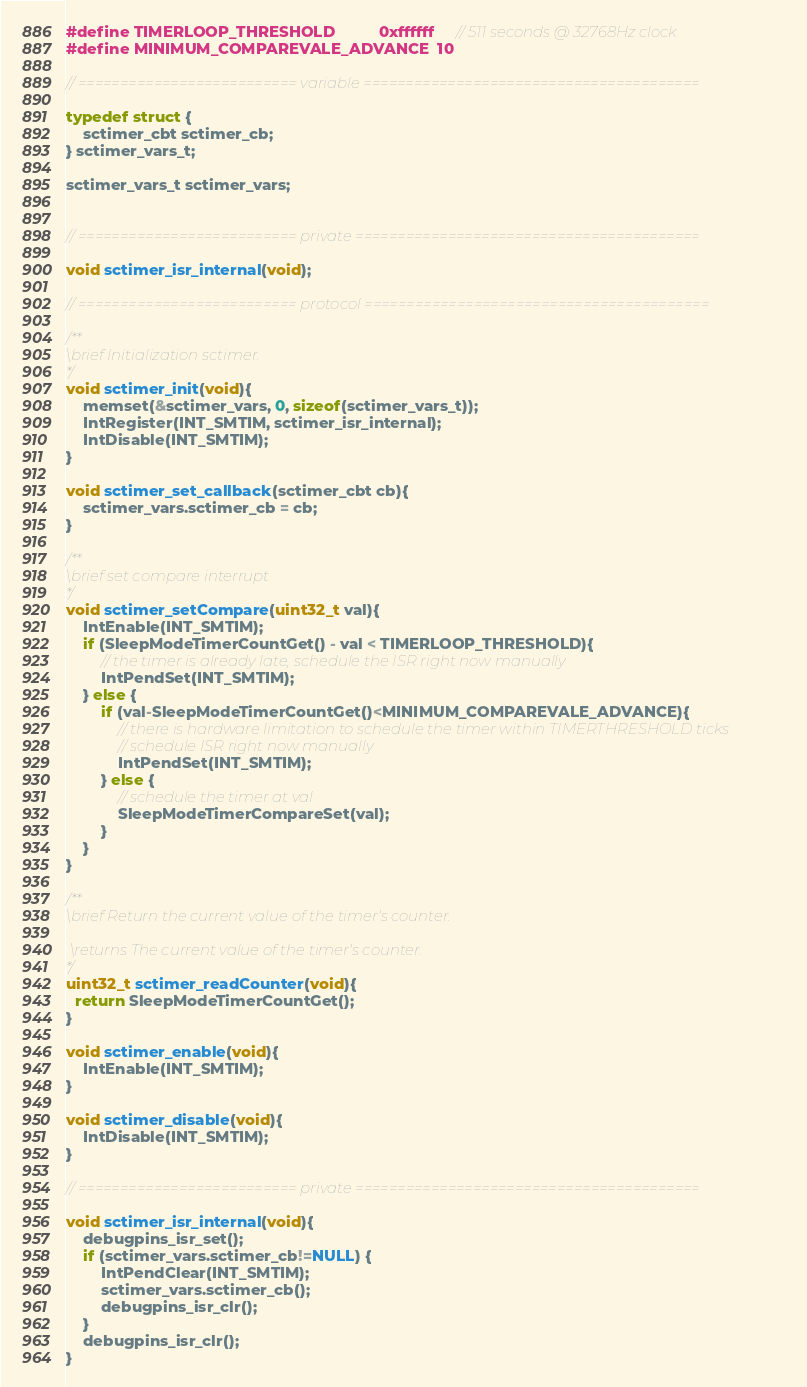Convert code to text. <code><loc_0><loc_0><loc_500><loc_500><_C_>
#define TIMERLOOP_THRESHOLD          0xffffff     // 511 seconds @ 32768Hz clock
#define MINIMUM_COMPAREVALE_ADVANCE  10

// ========================== variable ========================================

typedef struct {
    sctimer_cbt sctimer_cb;
} sctimer_vars_t;

sctimer_vars_t sctimer_vars;


// ========================== private =========================================

void sctimer_isr_internal(void);

// ========================== protocol =========================================

/**
\brief Initialization sctimer.
*/
void sctimer_init(void){
    memset(&sctimer_vars, 0, sizeof(sctimer_vars_t));
    IntRegister(INT_SMTIM, sctimer_isr_internal);
    IntDisable(INT_SMTIM);
}

void sctimer_set_callback(sctimer_cbt cb){
    sctimer_vars.sctimer_cb = cb;
}

/**
\brief set compare interrupt
*/
void sctimer_setCompare(uint32_t val){
    IntEnable(INT_SMTIM);
    if (SleepModeTimerCountGet() - val < TIMERLOOP_THRESHOLD){
        // the timer is already late, schedule the ISR right now manually 
        IntPendSet(INT_SMTIM);
    } else {
        if (val-SleepModeTimerCountGet()<MINIMUM_COMPAREVALE_ADVANCE){
            // there is hardware limitation to schedule the timer within TIMERTHRESHOLD ticks
            // schedule ISR right now manually
            IntPendSet(INT_SMTIM);
        } else {
            // schedule the timer at val
            SleepModeTimerCompareSet(val);
        }
    }
}

/**
\brief Return the current value of the timer's counter.

 \returns The current value of the timer's counter.
*/
uint32_t sctimer_readCounter(void){
  return SleepModeTimerCountGet();
}

void sctimer_enable(void){
    IntEnable(INT_SMTIM);
}

void sctimer_disable(void){
    IntDisable(INT_SMTIM);
}

// ========================== private =========================================

void sctimer_isr_internal(void){
    debugpins_isr_set();
    if (sctimer_vars.sctimer_cb!=NULL) {
        IntPendClear(INT_SMTIM);
        sctimer_vars.sctimer_cb();
        debugpins_isr_clr();
    }
    debugpins_isr_clr();
}</code> 